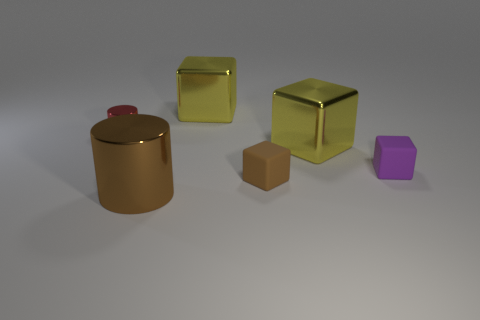There is a matte object that is the same color as the large cylinder; what size is it?
Make the answer very short. Small. What is the color of the big cylinder that is the same material as the small red cylinder?
Your answer should be compact. Brown. Does the purple thing have the same material as the cylinder to the left of the brown shiny thing?
Your answer should be very brief. No. What is the color of the small cylinder?
Provide a succinct answer. Red. There is a cylinder that is made of the same material as the large brown object; what is its size?
Make the answer very short. Small. There is a large metallic cube in front of the yellow object that is behind the red shiny cylinder; what number of big shiny cubes are in front of it?
Your answer should be very brief. 0. There is a large metal cylinder; is its color the same as the matte thing in front of the tiny purple thing?
Provide a succinct answer. Yes. What is the shape of the matte object that is the same color as the large cylinder?
Offer a very short reply. Cube. What material is the large cube right of the small matte thing that is on the left side of the small block that is behind the brown matte thing?
Offer a terse response. Metal. Is the shape of the large brown metal thing that is on the right side of the tiny cylinder the same as  the small red object?
Provide a succinct answer. Yes. 